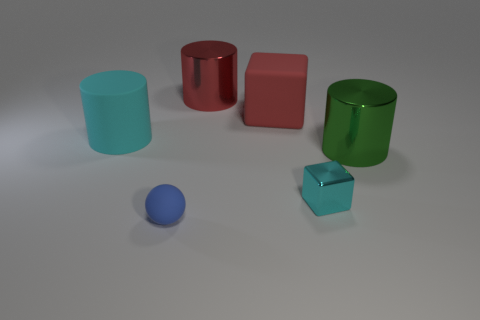What color is the cube that is made of the same material as the small blue thing?
Ensure brevity in your answer.  Red. Is there anything else that is the same size as the red shiny cylinder?
Provide a short and direct response. Yes. How many things are large red things in front of the red metallic thing or matte objects left of the big matte cube?
Your answer should be very brief. 3. Is the size of the rubber object that is left of the blue ball the same as the cube that is in front of the large cyan cylinder?
Offer a very short reply. No. There is a matte thing that is the same shape as the big green metal object; what color is it?
Your response must be concise. Cyan. Is there any other thing that is the same shape as the big cyan object?
Give a very brief answer. Yes. Is the number of large red matte objects right of the red cylinder greater than the number of large cyan rubber things left of the large red block?
Give a very brief answer. No. What size is the cyan thing left of the big metallic cylinder that is left of the large matte thing that is on the right side of the big red metal cylinder?
Offer a terse response. Large. Do the large cube and the big cylinder to the left of the big red metal thing have the same material?
Provide a succinct answer. Yes. Is the large cyan thing the same shape as the tiny shiny thing?
Ensure brevity in your answer.  No. 